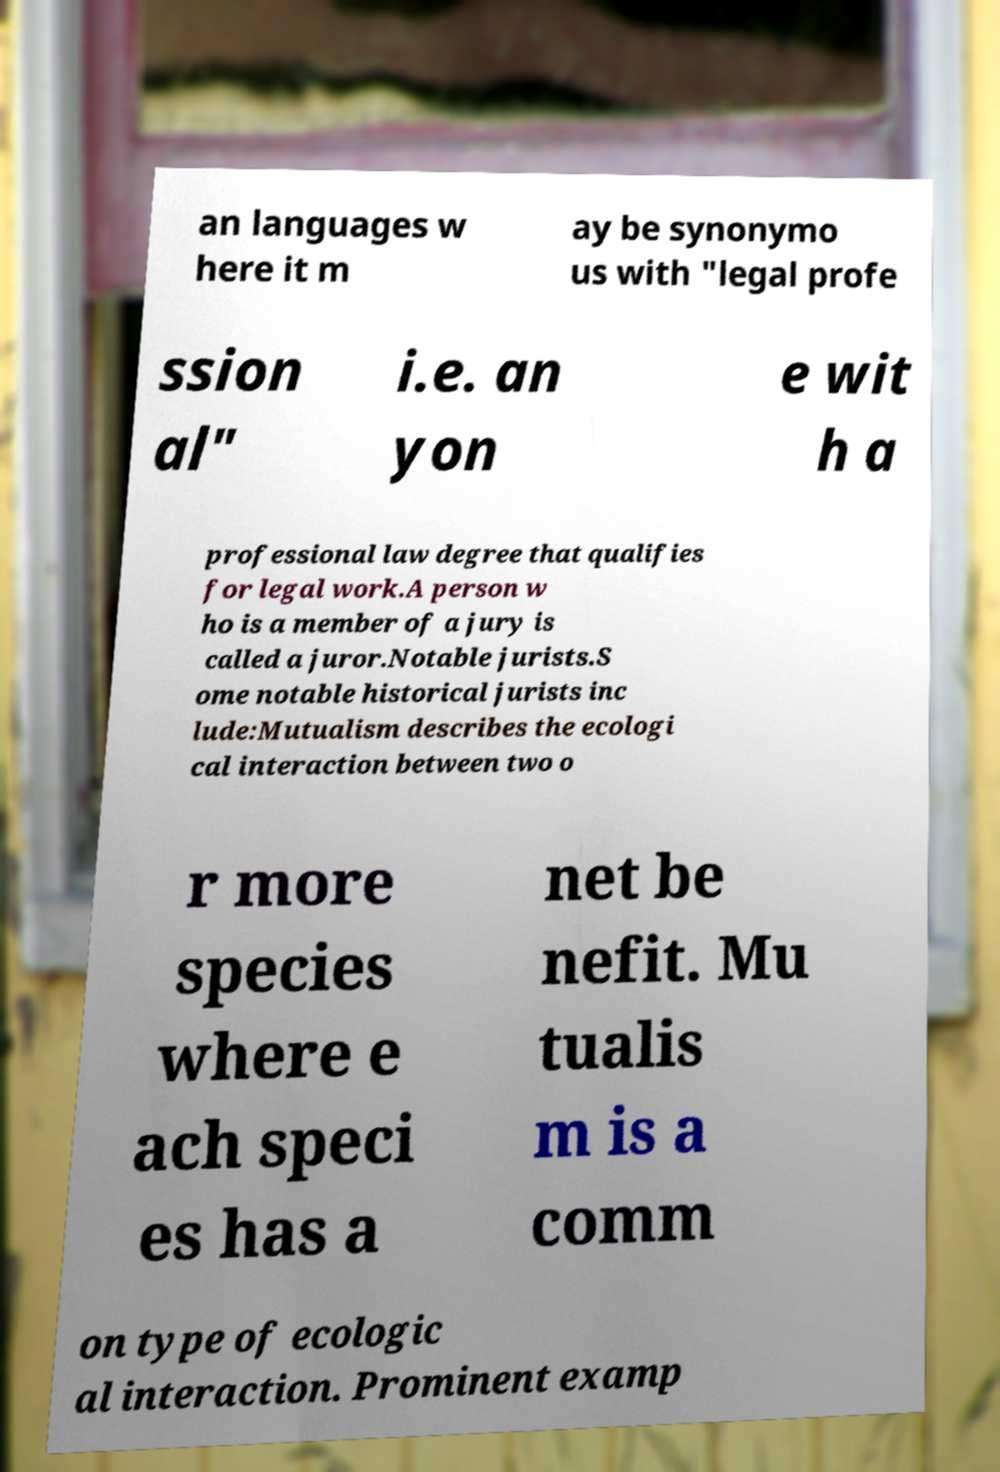Please read and relay the text visible in this image. What does it say? an languages w here it m ay be synonymo us with "legal profe ssion al" i.e. an yon e wit h a professional law degree that qualifies for legal work.A person w ho is a member of a jury is called a juror.Notable jurists.S ome notable historical jurists inc lude:Mutualism describes the ecologi cal interaction between two o r more species where e ach speci es has a net be nefit. Mu tualis m is a comm on type of ecologic al interaction. Prominent examp 